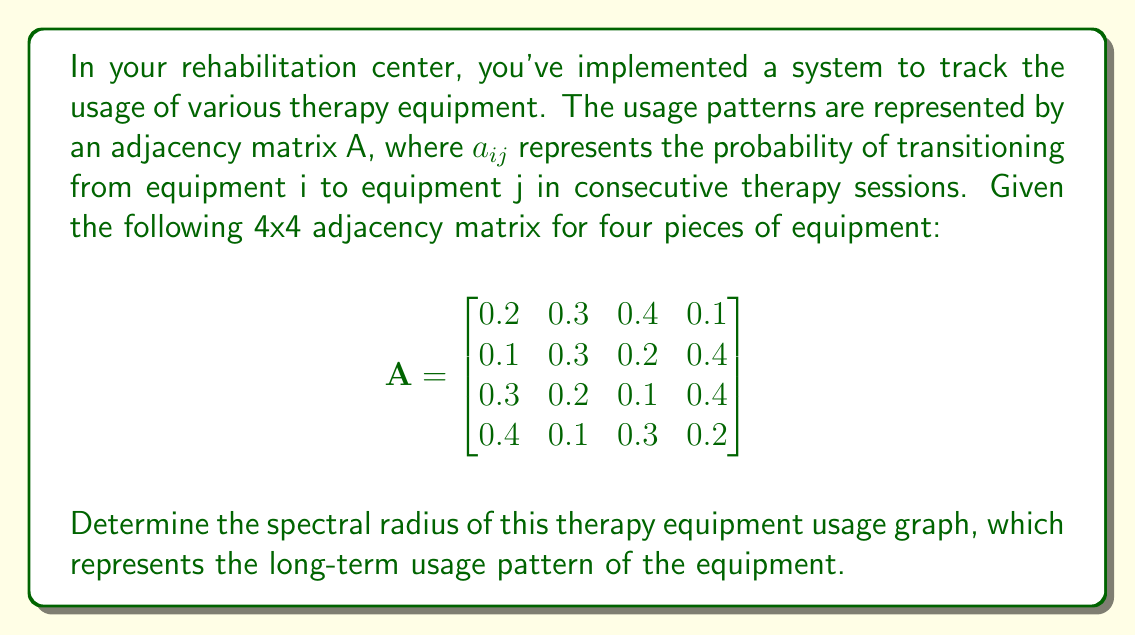Provide a solution to this math problem. To determine the spectral radius of the therapy equipment usage graph, we need to follow these steps:

1) The spectral radius is the largest absolute value of the eigenvalues of the matrix A.

2) To find the eigenvalues, we need to solve the characteristic equation:
   $\det(A - \lambda I) = 0$, where I is the 4x4 identity matrix.

3) Expanding the determinant:
   $$\begin{vmatrix}
   0.2-\lambda & 0.3 & 0.4 & 0.1 \\
   0.1 & 0.3-\lambda & 0.2 & 0.4 \\
   0.3 & 0.2 & 0.1-\lambda & 0.4 \\
   0.4 & 0.1 & 0.3 & 0.2-\lambda
   \end{vmatrix} = 0$$

4) This leads to a 4th degree polynomial equation:
   $\lambda^4 - 0.8\lambda^3 - 0.306\lambda^2 + 0.0944\lambda - 0.0081 = 0$

5) Solving this equation numerically (as it's difficult to solve analytically), we get the following eigenvalues:
   $\lambda_1 \approx 1$
   $\lambda_2 \approx -0.1$
   $\lambda_3 \approx -0.05 + 0.0866i$
   $\lambda_4 \approx -0.05 - 0.0866i$

6) The spectral radius is the maximum absolute value of these eigenvalues:
   $\rho(A) = \max(|\lambda_1|, |\lambda_2|, |\lambda_3|, |\lambda_4|) = |\lambda_1| = 1$

The spectral radius of 1 indicates that the usage pattern is stable in the long term, as expected for a stochastic matrix representing transition probabilities.
Answer: $\rho(A) = 1$ 